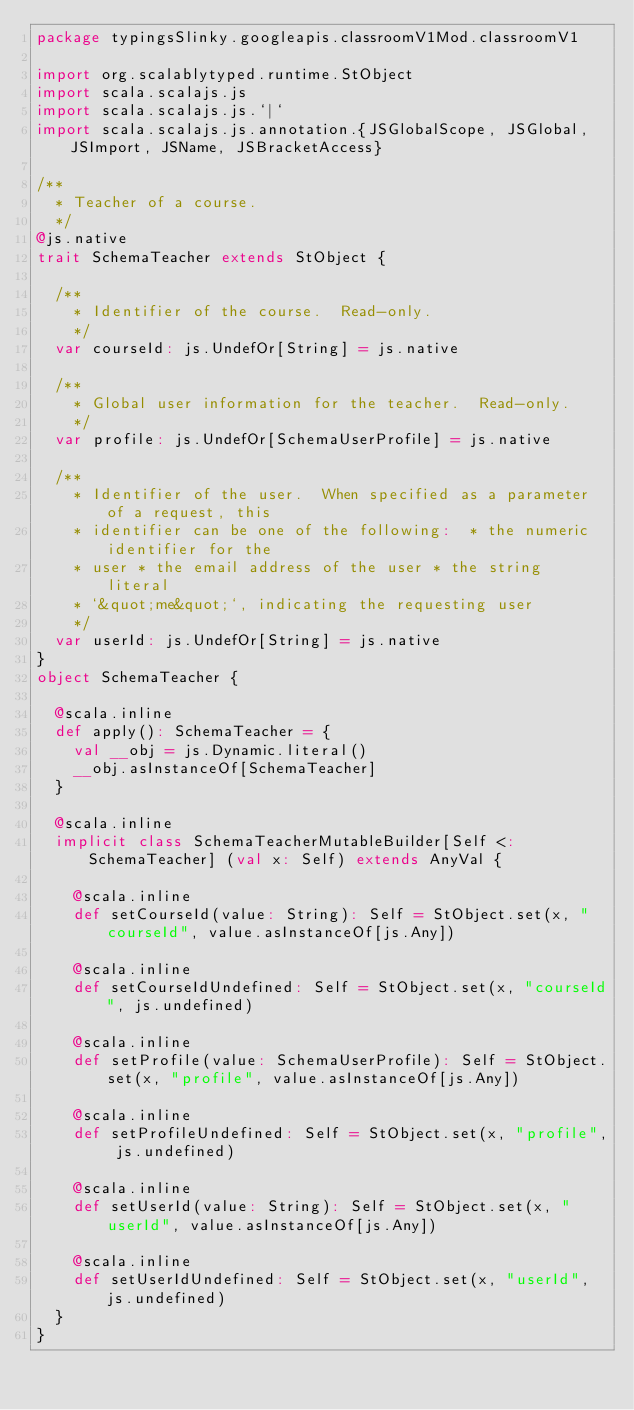<code> <loc_0><loc_0><loc_500><loc_500><_Scala_>package typingsSlinky.googleapis.classroomV1Mod.classroomV1

import org.scalablytyped.runtime.StObject
import scala.scalajs.js
import scala.scalajs.js.`|`
import scala.scalajs.js.annotation.{JSGlobalScope, JSGlobal, JSImport, JSName, JSBracketAccess}

/**
  * Teacher of a course.
  */
@js.native
trait SchemaTeacher extends StObject {
  
  /**
    * Identifier of the course.  Read-only.
    */
  var courseId: js.UndefOr[String] = js.native
  
  /**
    * Global user information for the teacher.  Read-only.
    */
  var profile: js.UndefOr[SchemaUserProfile] = js.native
  
  /**
    * Identifier of the user.  When specified as a parameter of a request, this
    * identifier can be one of the following:  * the numeric identifier for the
    * user * the email address of the user * the string literal
    * `&quot;me&quot;`, indicating the requesting user
    */
  var userId: js.UndefOr[String] = js.native
}
object SchemaTeacher {
  
  @scala.inline
  def apply(): SchemaTeacher = {
    val __obj = js.Dynamic.literal()
    __obj.asInstanceOf[SchemaTeacher]
  }
  
  @scala.inline
  implicit class SchemaTeacherMutableBuilder[Self <: SchemaTeacher] (val x: Self) extends AnyVal {
    
    @scala.inline
    def setCourseId(value: String): Self = StObject.set(x, "courseId", value.asInstanceOf[js.Any])
    
    @scala.inline
    def setCourseIdUndefined: Self = StObject.set(x, "courseId", js.undefined)
    
    @scala.inline
    def setProfile(value: SchemaUserProfile): Self = StObject.set(x, "profile", value.asInstanceOf[js.Any])
    
    @scala.inline
    def setProfileUndefined: Self = StObject.set(x, "profile", js.undefined)
    
    @scala.inline
    def setUserId(value: String): Self = StObject.set(x, "userId", value.asInstanceOf[js.Any])
    
    @scala.inline
    def setUserIdUndefined: Self = StObject.set(x, "userId", js.undefined)
  }
}
</code> 